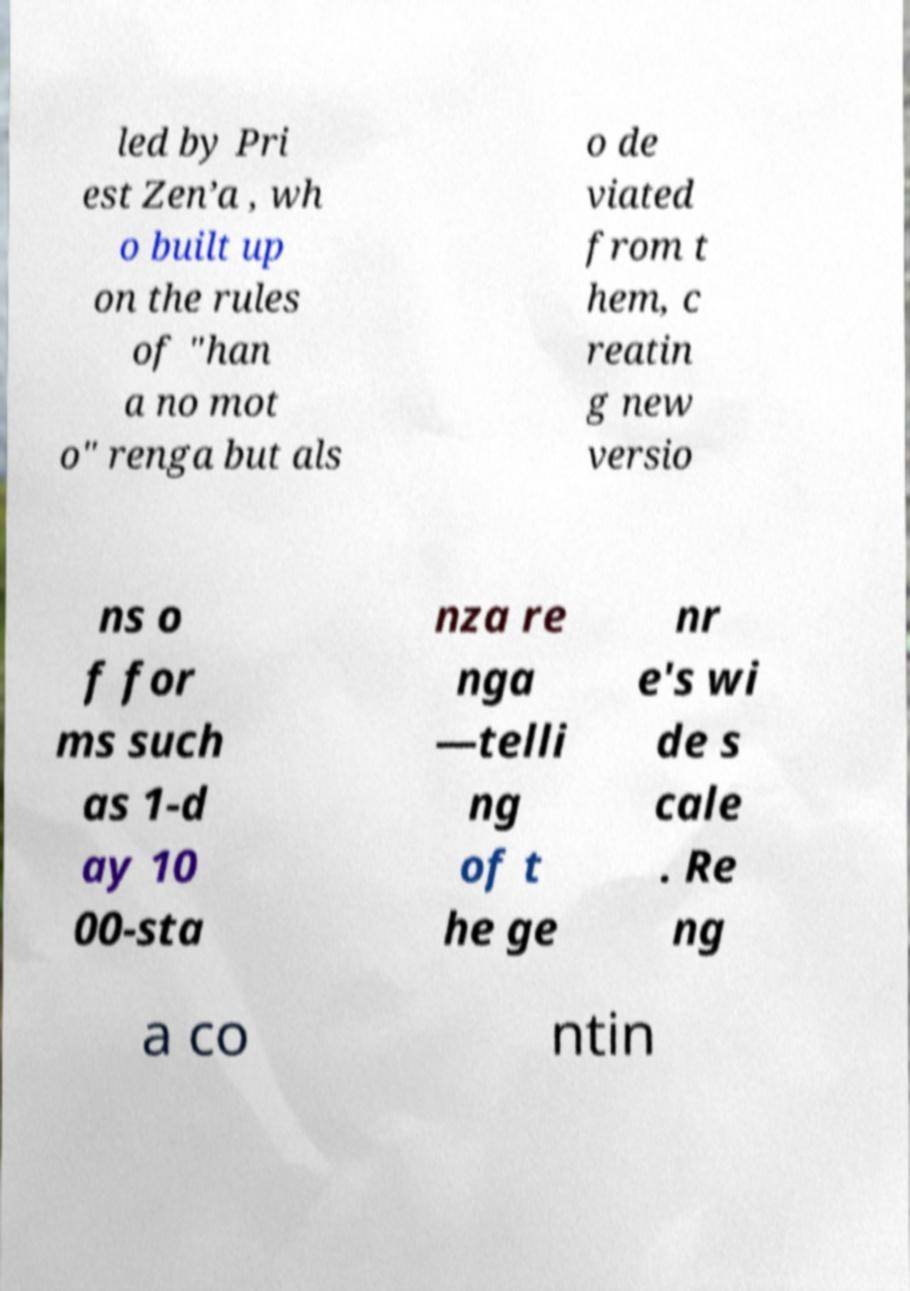I need the written content from this picture converted into text. Can you do that? led by Pri est Zen’a , wh o built up on the rules of "han a no mot o" renga but als o de viated from t hem, c reatin g new versio ns o f for ms such as 1-d ay 10 00-sta nza re nga —telli ng of t he ge nr e's wi de s cale . Re ng a co ntin 